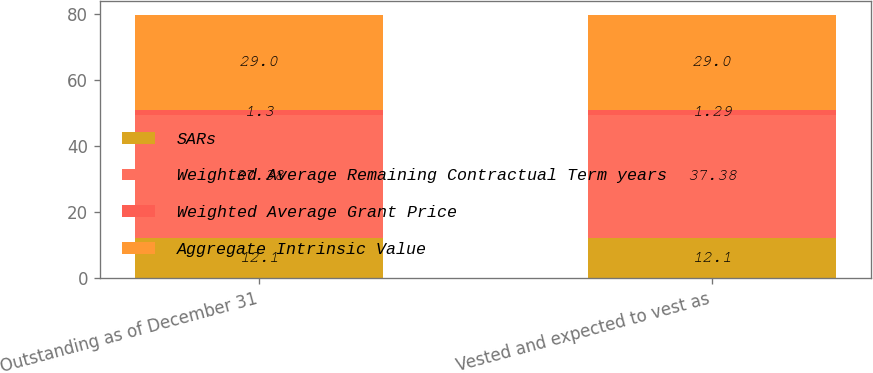<chart> <loc_0><loc_0><loc_500><loc_500><stacked_bar_chart><ecel><fcel>Outstanding as of December 31<fcel>Vested and expected to vest as<nl><fcel>SARs<fcel>12.1<fcel>12.1<nl><fcel>Weighted Average Remaining Contractual Term years<fcel>37.38<fcel>37.38<nl><fcel>Weighted Average Grant Price<fcel>1.3<fcel>1.29<nl><fcel>Aggregate Intrinsic Value<fcel>29<fcel>29<nl></chart> 